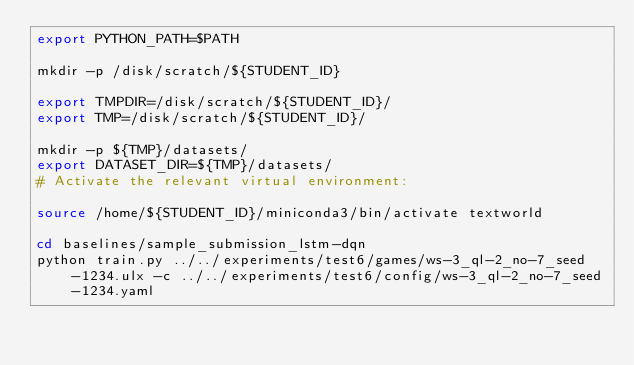Convert code to text. <code><loc_0><loc_0><loc_500><loc_500><_Bash_>export PYTHON_PATH=$PATH

mkdir -p /disk/scratch/${STUDENT_ID}

export TMPDIR=/disk/scratch/${STUDENT_ID}/
export TMP=/disk/scratch/${STUDENT_ID}/

mkdir -p ${TMP}/datasets/
export DATASET_DIR=${TMP}/datasets/
# Activate the relevant virtual environment:

source /home/${STUDENT_ID}/miniconda3/bin/activate textworld

cd baselines/sample_submission_lstm-dqn
python train.py ../../experiments/test6/games/ws-3_ql-2_no-7_seed-1234.ulx -c ../../experiments/test6/config/ws-3_ql-2_no-7_seed-1234.yaml
</code> 